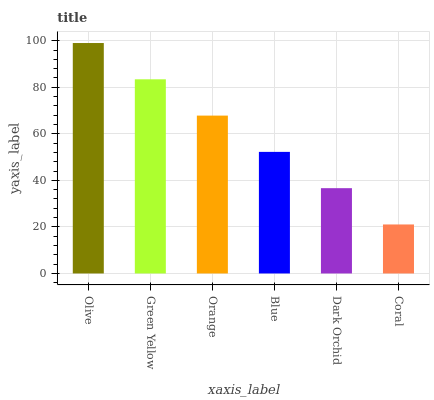Is Coral the minimum?
Answer yes or no. Yes. Is Olive the maximum?
Answer yes or no. Yes. Is Green Yellow the minimum?
Answer yes or no. No. Is Green Yellow the maximum?
Answer yes or no. No. Is Olive greater than Green Yellow?
Answer yes or no. Yes. Is Green Yellow less than Olive?
Answer yes or no. Yes. Is Green Yellow greater than Olive?
Answer yes or no. No. Is Olive less than Green Yellow?
Answer yes or no. No. Is Orange the high median?
Answer yes or no. Yes. Is Blue the low median?
Answer yes or no. Yes. Is Blue the high median?
Answer yes or no. No. Is Dark Orchid the low median?
Answer yes or no. No. 